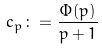<formula> <loc_0><loc_0><loc_500><loc_500>c _ { p } \colon = \frac { \Phi ( p ) } { p + 1 }</formula> 